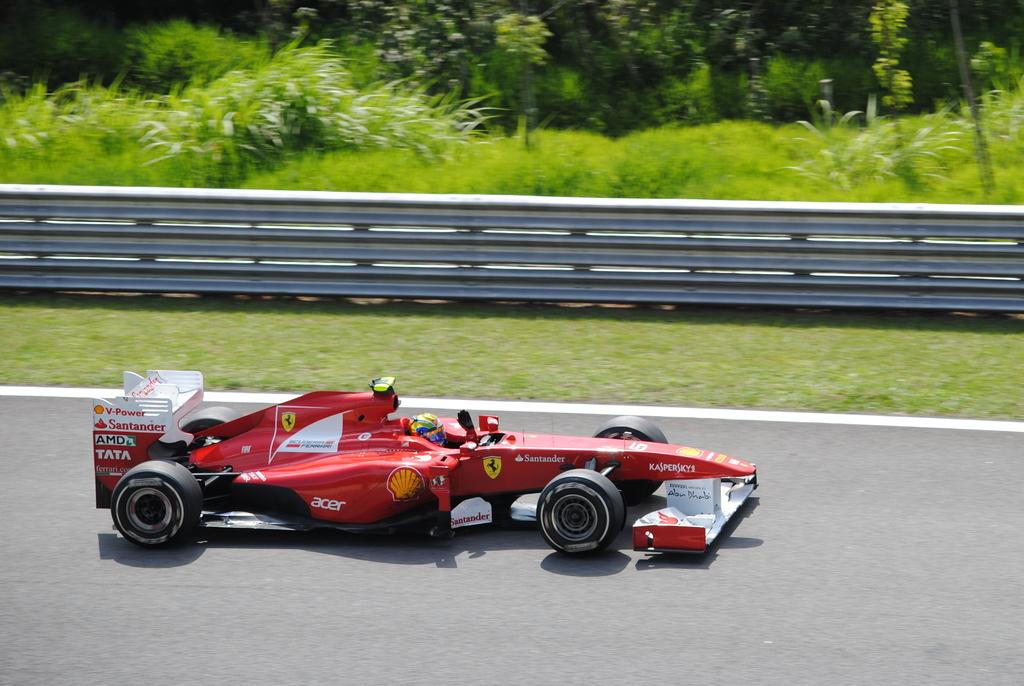What is happening on the road in the image? There is a racing event happening on the road in the image. What can be seen near the road in the image? There is railing visible in the image. What type of surface is the racing event taking place on? Grass is present on the ground in the image. Are there any plants visible in the image? Yes, there are plants in the image. Where can the fish be seen swimming in the image? There are no fish present in the image. What type of army equipment can be seen in the image? There is no army equipment present in the image. 